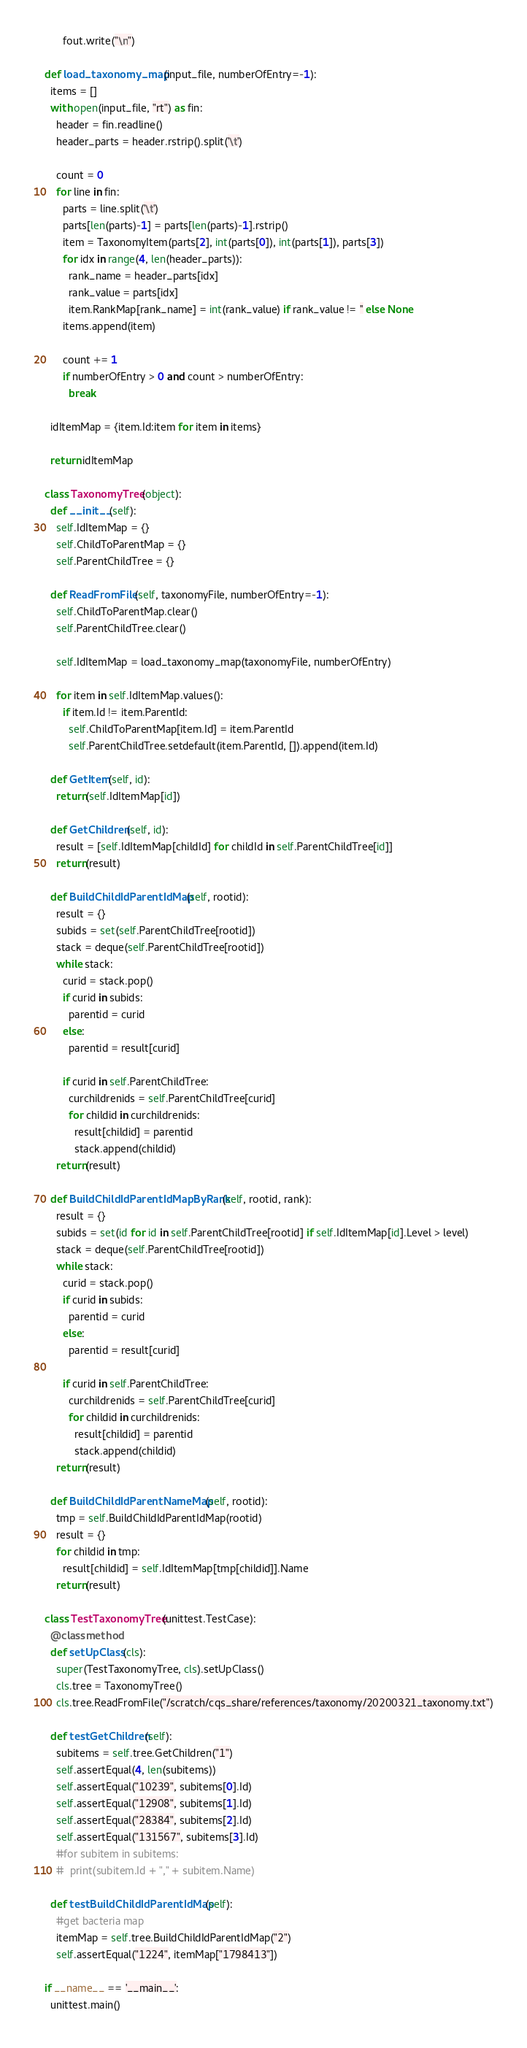Convert code to text. <code><loc_0><loc_0><loc_500><loc_500><_Python_>      fout.write("\n")

def load_taxonomy_map(input_file, numberOfEntry=-1):
  items = []
  with open(input_file, "rt") as fin:
    header = fin.readline()
    header_parts = header.rstrip().split('\t')

    count = 0
    for line in fin:
      parts = line.split('\t')
      parts[len(parts)-1] = parts[len(parts)-1].rstrip()
      item = TaxonomyItem(parts[2], int(parts[0]), int(parts[1]), parts[3])
      for idx in range(4, len(header_parts)):
        rank_name = header_parts[idx]
        rank_value = parts[idx]
        item.RankMap[rank_name] = int(rank_value) if rank_value != '' else None
      items.append(item)

      count += 1
      if numberOfEntry > 0 and count > numberOfEntry:
        break
    
  idItemMap = {item.Id:item for item in items}

  return idItemMap

class TaxonomyTree(object):
  def __init__(self):
    self.IdItemMap = {}
    self.ChildToParentMap = {}
    self.ParentChildTree = {}

  def ReadFromFile(self, taxonomyFile, numberOfEntry=-1):
    self.ChildToParentMap.clear()
    self.ParentChildTree.clear()

    self.IdItemMap = load_taxonomy_map(taxonomyFile, numberOfEntry)

    for item in self.IdItemMap.values():
      if item.Id != item.ParentId:
        self.ChildToParentMap[item.Id] = item.ParentId
        self.ParentChildTree.setdefault(item.ParentId, []).append(item.Id)

  def GetItem(self, id):
    return(self.IdItemMap[id])

  def GetChildren(self, id):
    result = [self.IdItemMap[childId] for childId in self.ParentChildTree[id]]
    return(result)

  def BuildChildIdParentIdMap(self, rootid):
    result = {}
    subids = set(self.ParentChildTree[rootid])
    stack = deque(self.ParentChildTree[rootid])
    while stack:
      curid = stack.pop()
      if curid in subids:
        parentid = curid
      else:
        parentid = result[curid]

      if curid in self.ParentChildTree:
        curchildrenids = self.ParentChildTree[curid]
        for childid in curchildrenids:
          result[childid] = parentid
          stack.append(childid)
    return(result)

  def BuildChildIdParentIdMapByRank(self, rootid, rank):
    result = {}
    subids = set(id for id in self.ParentChildTree[rootid] if self.IdItemMap[id].Level > level)
    stack = deque(self.ParentChildTree[rootid])
    while stack:
      curid = stack.pop()
      if curid in subids:
        parentid = curid
      else:
        parentid = result[curid]

      if curid in self.ParentChildTree:
        curchildrenids = self.ParentChildTree[curid]
        for childid in curchildrenids:
          result[childid] = parentid
          stack.append(childid)
    return(result)

  def BuildChildIdParentNameMap(self, rootid):
    tmp = self.BuildChildIdParentIdMap(rootid)
    result = {}
    for childid in tmp:
      result[childid] = self.IdItemMap[tmp[childid]].Name
    return(result)

class TestTaxonomyTree(unittest.TestCase):
  @classmethod
  def setUpClass(cls):
    super(TestTaxonomyTree, cls).setUpClass()
    cls.tree = TaxonomyTree()
    cls.tree.ReadFromFile("/scratch/cqs_share/references/taxonomy/20200321_taxonomy.txt")

  def testGetChildren(self):
    subitems = self.tree.GetChildren("1")
    self.assertEqual(4, len(subitems))
    self.assertEqual("10239", subitems[0].Id)
    self.assertEqual("12908", subitems[1].Id)
    self.assertEqual("28384", subitems[2].Id)
    self.assertEqual("131567", subitems[3].Id)
    #for subitem in subitems:
    #  print(subitem.Id + "," + subitem.Name)

  def testBuildChildIdParentIdMap(self):
    #get bacteria map
    itemMap = self.tree.BuildChildIdParentIdMap("2")
    self.assertEqual("1224", itemMap["1798413"])

if __name__ == '__main__':
  unittest.main()</code> 